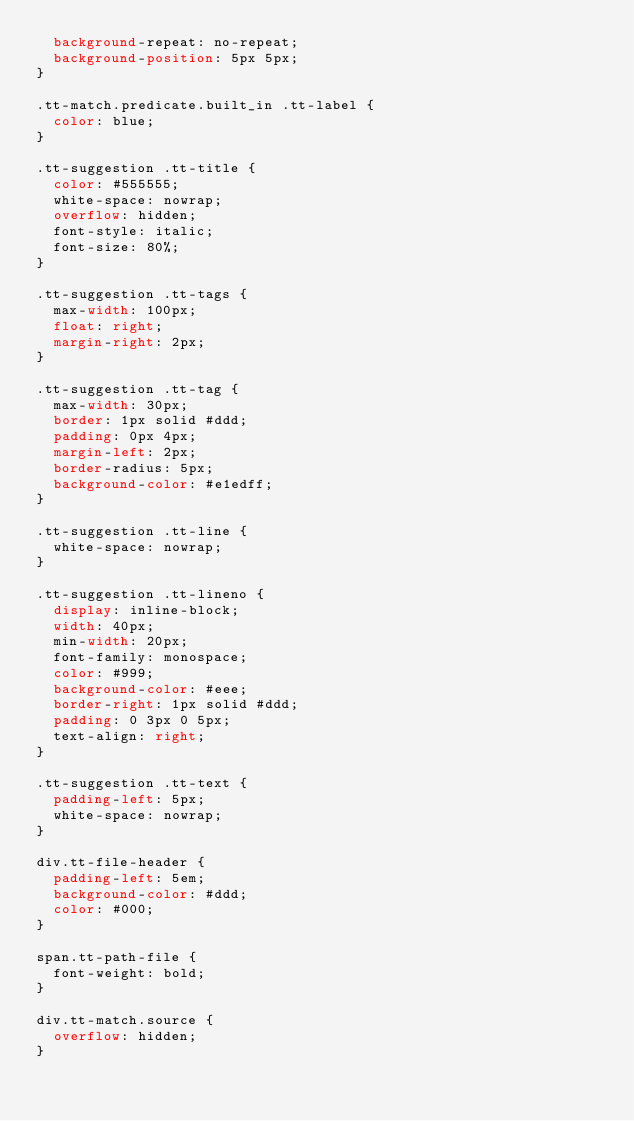Convert code to text. <code><loc_0><loc_0><loc_500><loc_500><_CSS_>  background-repeat: no-repeat;
  background-position: 5px 5px;
}

.tt-match.predicate.built_in .tt-label {
  color: blue;
}

.tt-suggestion .tt-title {
  color: #555555;
  white-space: nowrap;
  overflow: hidden;
  font-style: italic;
  font-size: 80%;
}

.tt-suggestion .tt-tags {
  max-width: 100px;
  float: right;
  margin-right: 2px;
}

.tt-suggestion .tt-tag {
  max-width: 30px;
  border: 1px solid #ddd;
  padding: 0px 4px;
  margin-left: 2px;
  border-radius: 5px;
  background-color: #e1edff;
}

.tt-suggestion .tt-line {
  white-space: nowrap;
}

.tt-suggestion .tt-lineno {
  display: inline-block;
  width: 40px;
  min-width: 20px;
  font-family: monospace;
  color: #999;
  background-color: #eee;
  border-right: 1px solid #ddd;
  padding: 0 3px 0 5px;
  text-align: right;
}

.tt-suggestion .tt-text {
  padding-left: 5px;
  white-space: nowrap;
}

div.tt-file-header {
  padding-left: 5em;
  background-color: #ddd;
  color: #000;
}

span.tt-path-file {
  font-weight: bold;
}

div.tt-match.source {
  overflow: hidden;
}
</code> 